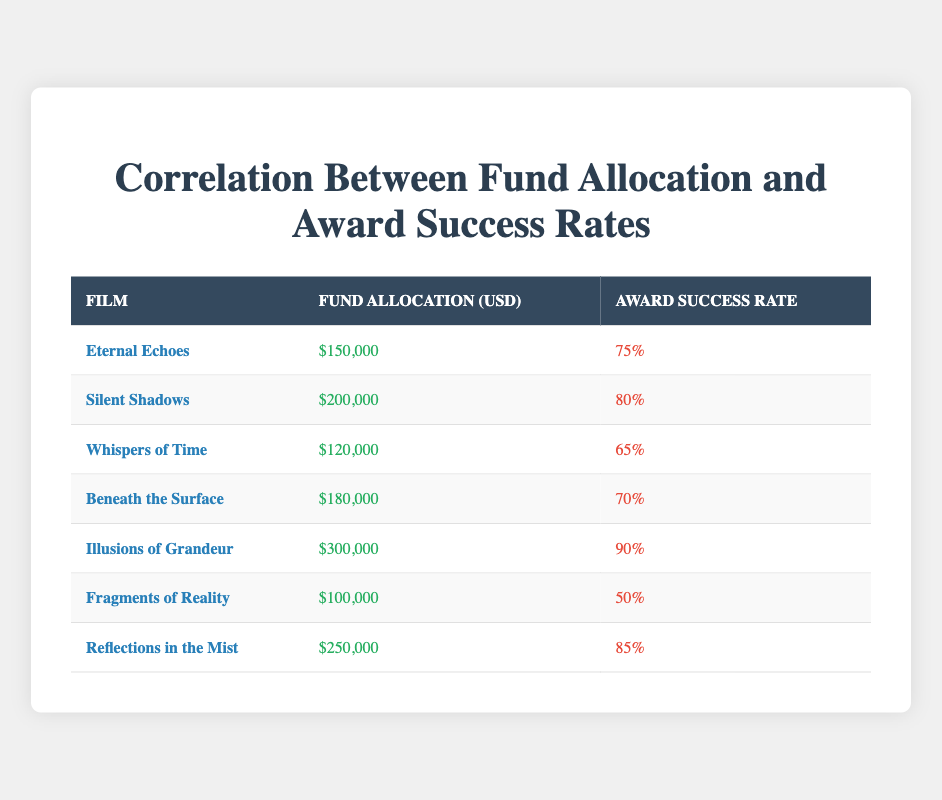What is the highest fund allocation among the films? The film with the highest fund allocation is "Illusions of Grandeur," with an allocation of $300,000. This value can be directly identified from the table.
Answer: $300,000 What is the award success rate for "Whispers of Time"? The award success rate for "Whispers of Time" is 65%, as shown in the corresponding row in the table.
Answer: 65% Is the award success rate for "Fragments of Reality" greater than 70%? "Fragments of Reality" has an award success rate of 50%, which is not greater than 70%. Hence, the answer is no.
Answer: No What film had the second highest award success rate? The award success rates from highest to lowest are: "Illusions of Grandeur" (90%), "Reflections in the Mist" (85%), "Silent Shadows" (80%). Therefore, "Reflections in the Mist" is the film with the second highest award success rate.
Answer: Reflections in the Mist What is the average fund allocation for all films listed? To calculate the average, add all fund allocations: 150,000 + 200,000 + 120,000 + 180,000 + 300,000 + 100,000 + 250,000 = 1,300,000. Then divide by the number of films (7): 1,300,000 / 7 = 185,714.28.
Answer: 185,714.28 Which film has the lowest award success rate? "Fragments of Reality" has the lowest award success rate at 50%. This can be directly derived from the table's award success rates when compared.
Answer: Fragments of Reality What is the difference in award success rates between "Illusions of Grandeur" and "Beneath the Surface"? "Illusions of Grandeur" has a success rate of 90%, while "Beneath the Surface" has 70%. The difference is calculated as 90% - 70% = 20%.
Answer: 20% Are there more films with an award success rate over 75% than films below 75%? The films with an award success rate over 75% are "Eternal Echoes," "Silent Shadows," "Illusions of Grandeur," and "Reflections in the Mist" (4 films), whereas those below 75% are "Whispers of Time," "Beneath the Surface," and "Fragments of Reality" (3 films). Thus, there are indeed more films with an award success rate over 75%.
Answer: Yes 